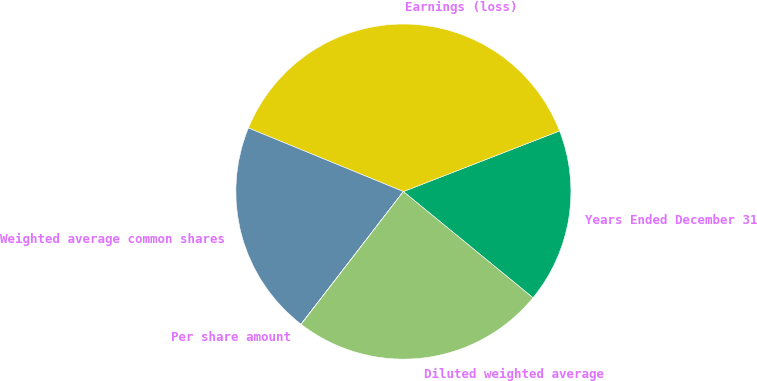<chart> <loc_0><loc_0><loc_500><loc_500><pie_chart><fcel>Years Ended December 31<fcel>Earnings (loss)<fcel>Weighted average common shares<fcel>Per share amount<fcel>Diluted weighted average<nl><fcel>16.82%<fcel>37.91%<fcel>20.73%<fcel>0.02%<fcel>24.52%<nl></chart> 